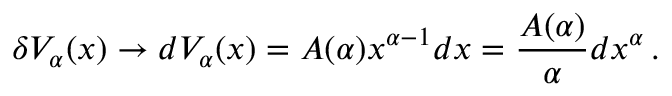<formula> <loc_0><loc_0><loc_500><loc_500>\delta V _ { \alpha } ( x ) \rightarrow d V _ { \alpha } ( x ) = A ( \alpha ) x ^ { \alpha - 1 } d x = \frac { A ( \alpha ) } { \alpha } d x ^ { \alpha } \, .</formula> 